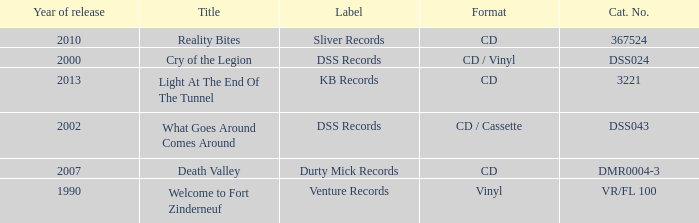What is the latest year of the album with the release title death valley? 2007.0. 